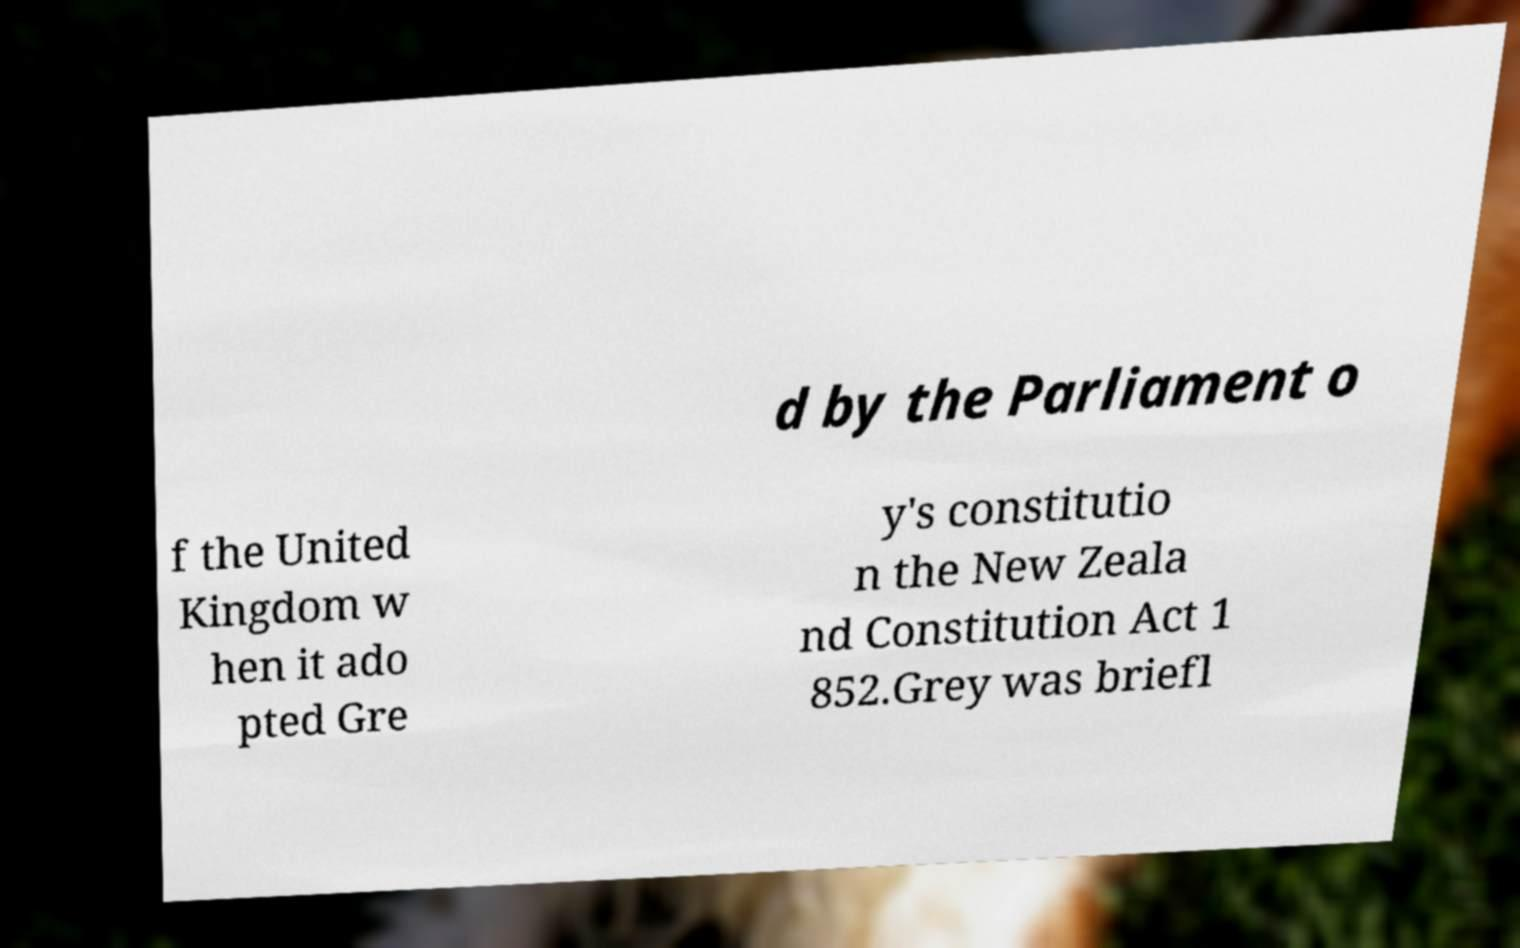Can you accurately transcribe the text from the provided image for me? d by the Parliament o f the United Kingdom w hen it ado pted Gre y's constitutio n the New Zeala nd Constitution Act 1 852.Grey was briefl 